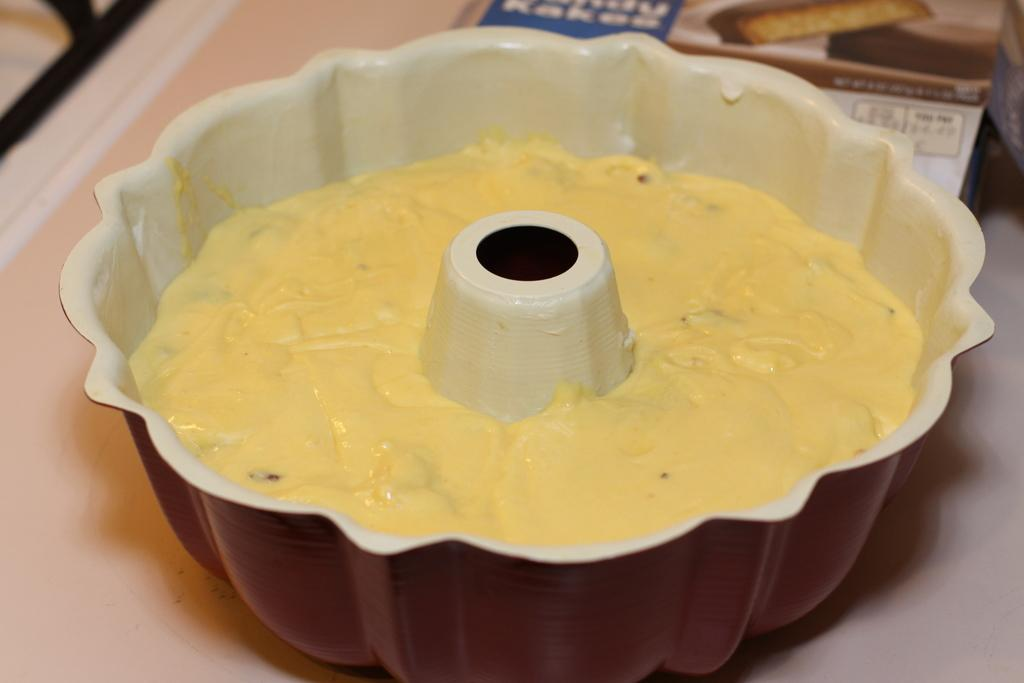What is the primary element in the image that contains fluid? There is fluid in an object in the image. Can you describe any other objects present in the image? Yes, there are other objects present in the image. What type of bed can be seen in the image? There is no bed present in the image. 